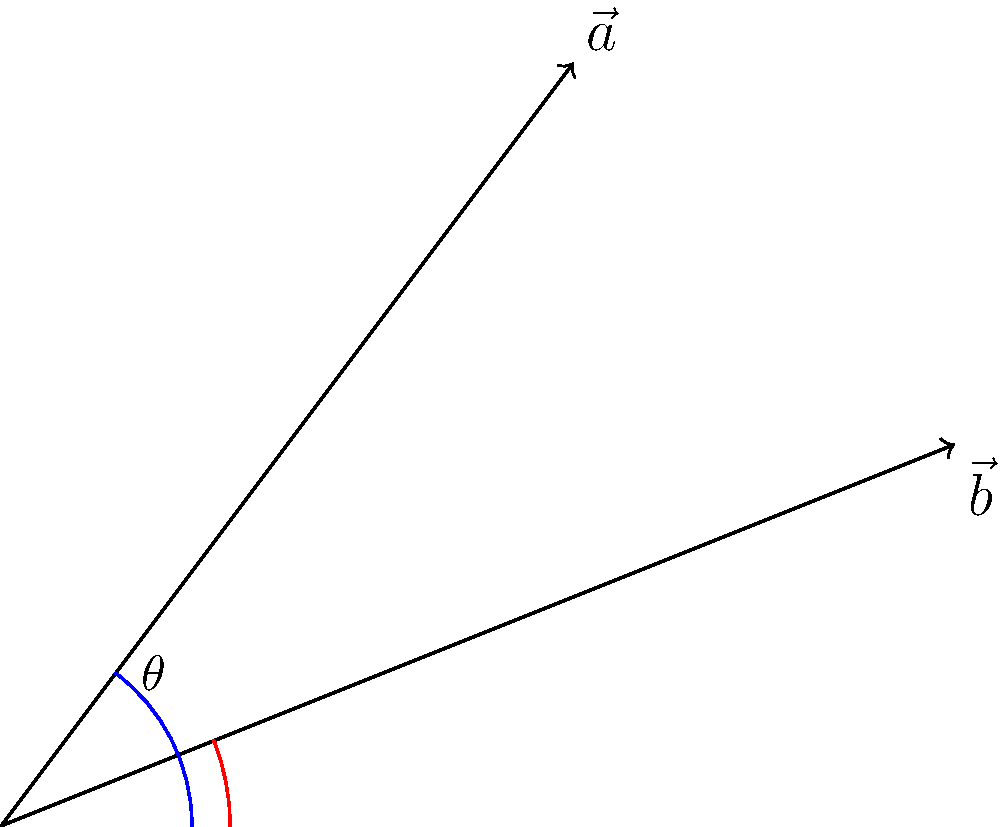At Old Soul Tattoo, you're discussing needle techniques with your artist. They show you two tattoo needle vectors $\vec{a} = (3,4)$ and $\vec{b} = (5,2)$. What is the angle between these two vectors in degrees, rounded to the nearest whole number? To find the angle between two vectors, we can use the dot product formula:

$$\cos \theta = \frac{\vec{a} \cdot \vec{b}}{|\vec{a}||\vec{b}|}$$

Step 1: Calculate the dot product $\vec{a} \cdot \vec{b}$
$$\vec{a} \cdot \vec{b} = (3)(5) + (4)(2) = 15 + 8 = 23$$

Step 2: Calculate the magnitudes of $\vec{a}$ and $\vec{b}$
$$|\vec{a}| = \sqrt{3^2 + 4^2} = \sqrt{9 + 16} = \sqrt{25} = 5$$
$$|\vec{b}| = \sqrt{5^2 + 2^2} = \sqrt{25 + 4} = \sqrt{29}$$

Step 3: Apply the formula
$$\cos \theta = \frac{23}{5\sqrt{29}}$$

Step 4: Take the inverse cosine (arccos) of both sides
$$\theta = \arccos(\frac{23}{5\sqrt{29}})$$

Step 5: Convert to degrees and round to the nearest whole number
$$\theta \approx 22°$$
Answer: 22° 